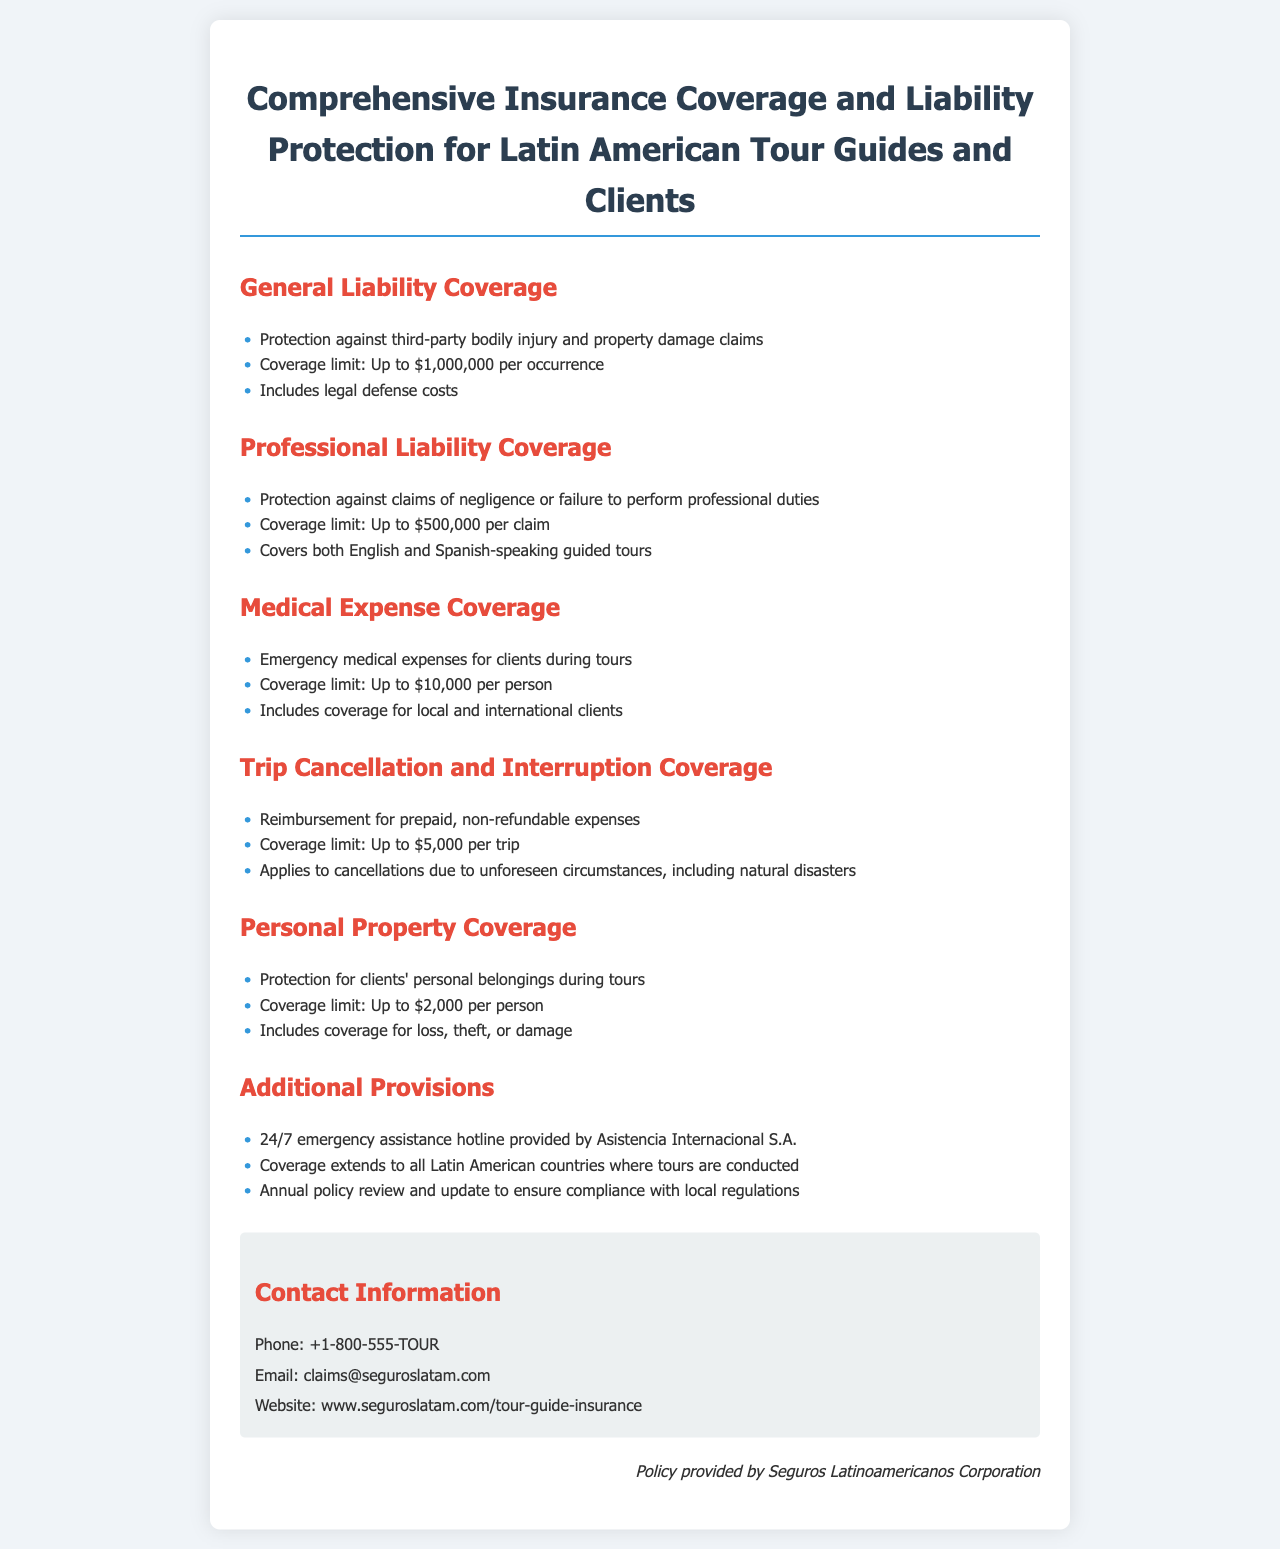What is the coverage limit for general liability? The coverage limit for general liability is the maximum amount provided for claims, which is up to $1,000,000 per occurrence.
Answer: Up to $1,000,000 per occurrence What types of tours are covered under professional liability? Professional liability coverage specifically mentions the types of guided tours it protects, which include both English and Spanish-speaking guided tours.
Answer: English and Spanish-speaking guided tours What is the medical expense coverage limit per person? The medical expense coverage limit indicates the maximum emergency medical expenses provided for each client during tours, which is specified in the document.
Answer: Up to $10,000 per person What is the reimbursement limit for trip cancellation? The reimbursement limit defines the maximum amount that can be claimed for trip cancellation and is outlined in the document under that section.
Answer: Up to $5,000 per trip Who provides the 24/7 emergency assistance hotline? The document specifies the provider of the emergency assistance hotline, which ensures support during tours, reflecting the company responsible for it.
Answer: Asistencia Internacional S.A What is the maximum coverage for personal property per person? The maximum coverage amount for personal belongings during tours is clearly stated in the document under the personal property coverage section.
Answer: Up to $2,000 per person What is included in the additional provisions section? The additional provisions section lists specific features that enhance the policy, showing comprehensive support measures outlined in that part of the document.
Answer: 24/7 emergency assistance hotline What type of document is this? The document's title and content reveal the nature of the information it provides, which is key to understanding its purpose and scope.
Answer: Insurance Policy 